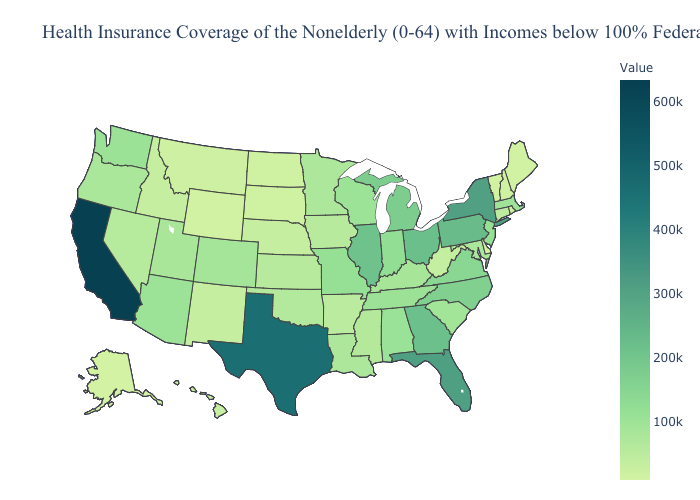Does Oregon have a higher value than North Carolina?
Give a very brief answer. No. Does Arkansas have the lowest value in the USA?
Short answer required. No. Which states have the lowest value in the MidWest?
Write a very short answer. North Dakota. Does New York have the highest value in the Northeast?
Quick response, please. Yes. Does the map have missing data?
Keep it brief. No. 